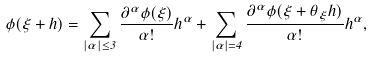<formula> <loc_0><loc_0><loc_500><loc_500>\phi ( \xi + h ) = \sum _ { | \alpha | \leq 3 } \frac { \partial ^ { \alpha } \phi ( \xi ) } { \alpha ! } h ^ { \alpha } + \sum _ { | \alpha | = 4 } \frac { \partial ^ { \alpha } \phi ( \xi + \theta _ { \xi } h ) } { \alpha ! } h ^ { \alpha } ,</formula> 